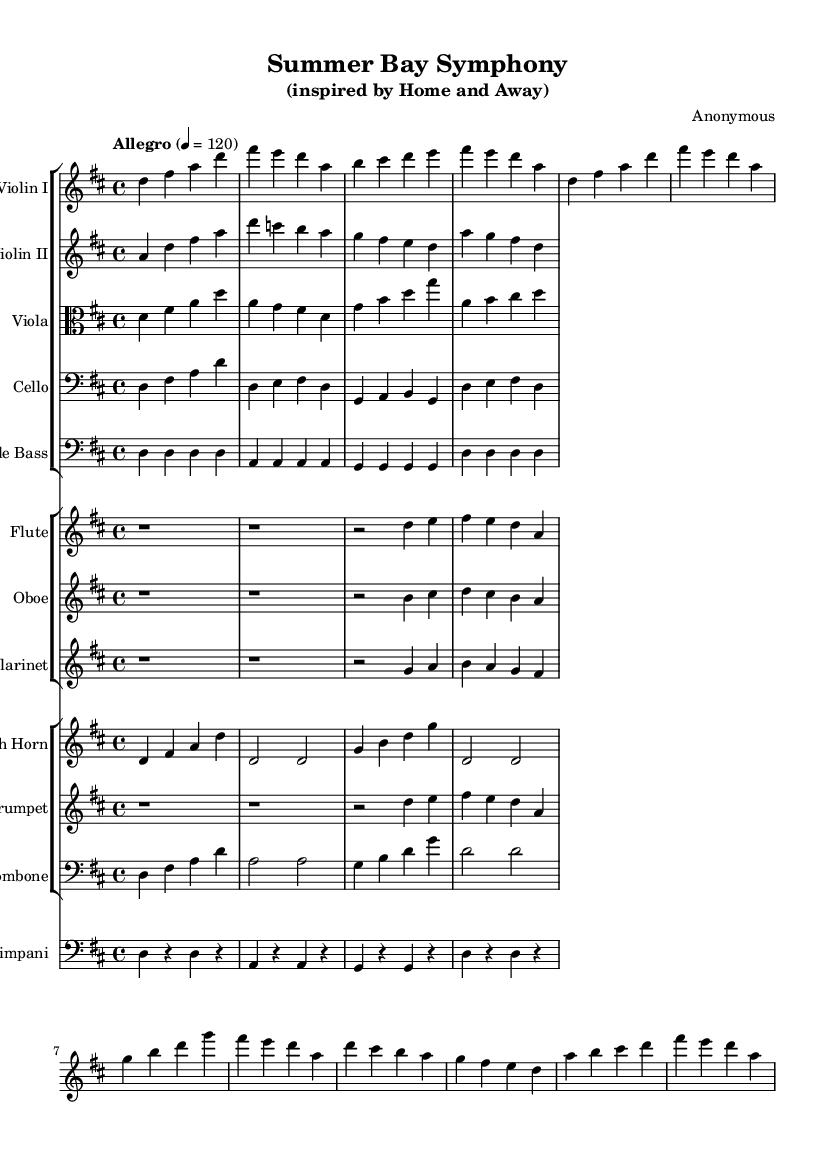what is the key signature of this music? The key signature is D major, which has two sharps (F# and C#) indicated at the beginning of the staff.
Answer: D major what is the time signature of this music? The time signature is 4/4, which is indicated at the beginning of the score, meaning there are 4 beats in each measure.
Answer: 4/4 what is the tempo marking in the score? The tempo marking is "Allegro," which indicates a fast and lively tempo, along with the metronome marking of 120 beats per minute (4 = 120).
Answer: Allegro how many measures are in the introduction? The introduction consists of 4 measures, which can be counted by looking at the slashes separating each set of notes.
Answer: 4 which instruments have simplified parts in this symphony? The instruments with simplified parts are Violin II, Viola, Cello, Double Bass, Flute, Oboe, Clarinet, French Horn, Trumpet, and Trombone. They all have fewer notes compared to Violin I.
Answer: Violin II, Viola, Cello, Double Bass, Flute, Oboe, Clarinet, French Horn, Trumpet, Trombone what is the name of this symphony? The symphony is titled "Summer Bay Symphony," reflecting its inspiration from the show "Home and Away."
Answer: Summer Bay Symphony which instruments play the same melody in the chorus? The instruments that play the same melody in the chorus section are Violin I and Trumpet, indicated by the similar note sequences during that part of the score.
Answer: Violin I, Trumpet 